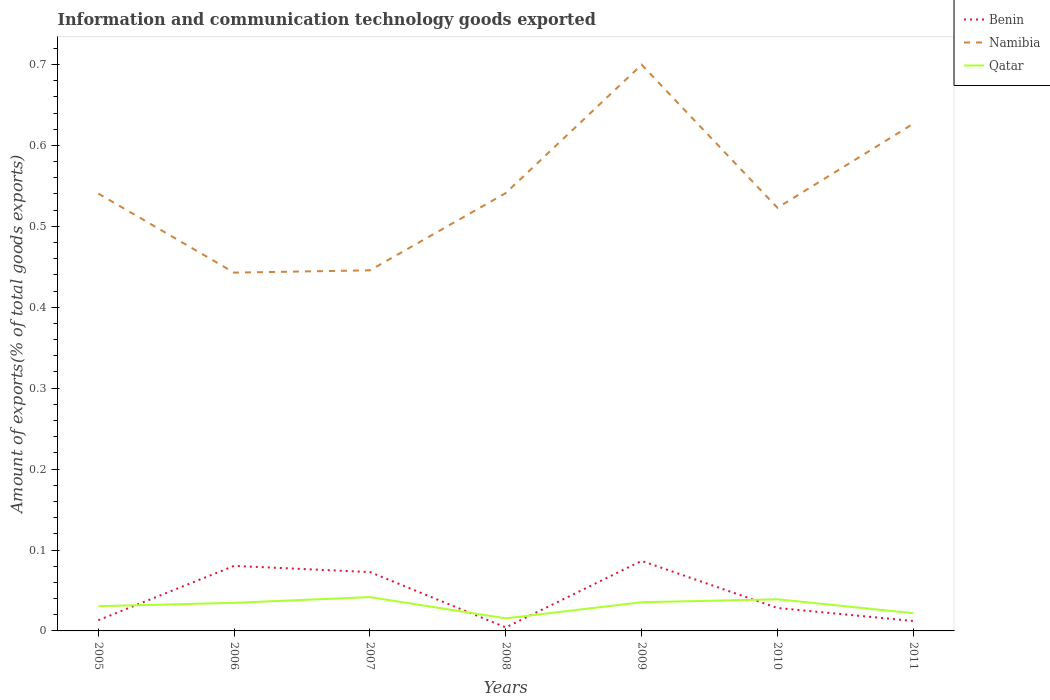How many different coloured lines are there?
Keep it short and to the point. 3. Does the line corresponding to Namibia intersect with the line corresponding to Qatar?
Your answer should be compact. No. Is the number of lines equal to the number of legend labels?
Your answer should be compact. Yes. Across all years, what is the maximum amount of goods exported in Benin?
Your response must be concise. 0. What is the total amount of goods exported in Qatar in the graph?
Offer a terse response. -0. What is the difference between the highest and the second highest amount of goods exported in Namibia?
Keep it short and to the point. 0.26. What is the difference between the highest and the lowest amount of goods exported in Benin?
Provide a succinct answer. 3. Are the values on the major ticks of Y-axis written in scientific E-notation?
Your answer should be very brief. No. Does the graph contain any zero values?
Your response must be concise. No. How many legend labels are there?
Provide a succinct answer. 3. What is the title of the graph?
Provide a short and direct response. Information and communication technology goods exported. What is the label or title of the Y-axis?
Give a very brief answer. Amount of exports(% of total goods exports). What is the Amount of exports(% of total goods exports) of Benin in 2005?
Provide a short and direct response. 0.01. What is the Amount of exports(% of total goods exports) of Namibia in 2005?
Offer a very short reply. 0.54. What is the Amount of exports(% of total goods exports) in Qatar in 2005?
Offer a very short reply. 0.03. What is the Amount of exports(% of total goods exports) of Benin in 2006?
Make the answer very short. 0.08. What is the Amount of exports(% of total goods exports) in Namibia in 2006?
Provide a succinct answer. 0.44. What is the Amount of exports(% of total goods exports) in Qatar in 2006?
Your response must be concise. 0.03. What is the Amount of exports(% of total goods exports) of Benin in 2007?
Give a very brief answer. 0.07. What is the Amount of exports(% of total goods exports) in Namibia in 2007?
Your answer should be compact. 0.45. What is the Amount of exports(% of total goods exports) of Qatar in 2007?
Provide a short and direct response. 0.04. What is the Amount of exports(% of total goods exports) in Benin in 2008?
Offer a very short reply. 0. What is the Amount of exports(% of total goods exports) in Namibia in 2008?
Ensure brevity in your answer.  0.54. What is the Amount of exports(% of total goods exports) in Qatar in 2008?
Ensure brevity in your answer.  0.02. What is the Amount of exports(% of total goods exports) in Benin in 2009?
Provide a short and direct response. 0.09. What is the Amount of exports(% of total goods exports) of Namibia in 2009?
Make the answer very short. 0.7. What is the Amount of exports(% of total goods exports) of Qatar in 2009?
Provide a short and direct response. 0.04. What is the Amount of exports(% of total goods exports) in Benin in 2010?
Ensure brevity in your answer.  0.03. What is the Amount of exports(% of total goods exports) of Namibia in 2010?
Provide a succinct answer. 0.52. What is the Amount of exports(% of total goods exports) of Qatar in 2010?
Provide a succinct answer. 0.04. What is the Amount of exports(% of total goods exports) in Benin in 2011?
Make the answer very short. 0.01. What is the Amount of exports(% of total goods exports) of Namibia in 2011?
Ensure brevity in your answer.  0.63. What is the Amount of exports(% of total goods exports) of Qatar in 2011?
Offer a terse response. 0.02. Across all years, what is the maximum Amount of exports(% of total goods exports) of Benin?
Your response must be concise. 0.09. Across all years, what is the maximum Amount of exports(% of total goods exports) of Namibia?
Your answer should be compact. 0.7. Across all years, what is the maximum Amount of exports(% of total goods exports) in Qatar?
Give a very brief answer. 0.04. Across all years, what is the minimum Amount of exports(% of total goods exports) of Benin?
Your answer should be compact. 0. Across all years, what is the minimum Amount of exports(% of total goods exports) in Namibia?
Your answer should be very brief. 0.44. Across all years, what is the minimum Amount of exports(% of total goods exports) in Qatar?
Your answer should be compact. 0.02. What is the total Amount of exports(% of total goods exports) of Benin in the graph?
Keep it short and to the point. 0.3. What is the total Amount of exports(% of total goods exports) in Namibia in the graph?
Make the answer very short. 3.82. What is the total Amount of exports(% of total goods exports) in Qatar in the graph?
Keep it short and to the point. 0.22. What is the difference between the Amount of exports(% of total goods exports) in Benin in 2005 and that in 2006?
Offer a terse response. -0.07. What is the difference between the Amount of exports(% of total goods exports) of Namibia in 2005 and that in 2006?
Your response must be concise. 0.1. What is the difference between the Amount of exports(% of total goods exports) in Qatar in 2005 and that in 2006?
Offer a terse response. -0. What is the difference between the Amount of exports(% of total goods exports) of Benin in 2005 and that in 2007?
Provide a succinct answer. -0.06. What is the difference between the Amount of exports(% of total goods exports) of Namibia in 2005 and that in 2007?
Offer a terse response. 0.09. What is the difference between the Amount of exports(% of total goods exports) of Qatar in 2005 and that in 2007?
Your answer should be very brief. -0.01. What is the difference between the Amount of exports(% of total goods exports) in Benin in 2005 and that in 2008?
Provide a short and direct response. 0.01. What is the difference between the Amount of exports(% of total goods exports) of Namibia in 2005 and that in 2008?
Your answer should be very brief. -0. What is the difference between the Amount of exports(% of total goods exports) in Qatar in 2005 and that in 2008?
Ensure brevity in your answer.  0.01. What is the difference between the Amount of exports(% of total goods exports) in Benin in 2005 and that in 2009?
Your response must be concise. -0.07. What is the difference between the Amount of exports(% of total goods exports) in Namibia in 2005 and that in 2009?
Ensure brevity in your answer.  -0.16. What is the difference between the Amount of exports(% of total goods exports) of Qatar in 2005 and that in 2009?
Offer a terse response. -0. What is the difference between the Amount of exports(% of total goods exports) of Benin in 2005 and that in 2010?
Your answer should be very brief. -0.02. What is the difference between the Amount of exports(% of total goods exports) in Namibia in 2005 and that in 2010?
Ensure brevity in your answer.  0.02. What is the difference between the Amount of exports(% of total goods exports) in Qatar in 2005 and that in 2010?
Offer a terse response. -0.01. What is the difference between the Amount of exports(% of total goods exports) of Namibia in 2005 and that in 2011?
Provide a short and direct response. -0.09. What is the difference between the Amount of exports(% of total goods exports) of Qatar in 2005 and that in 2011?
Keep it short and to the point. 0.01. What is the difference between the Amount of exports(% of total goods exports) in Benin in 2006 and that in 2007?
Make the answer very short. 0.01. What is the difference between the Amount of exports(% of total goods exports) of Namibia in 2006 and that in 2007?
Ensure brevity in your answer.  -0. What is the difference between the Amount of exports(% of total goods exports) in Qatar in 2006 and that in 2007?
Give a very brief answer. -0.01. What is the difference between the Amount of exports(% of total goods exports) of Benin in 2006 and that in 2008?
Make the answer very short. 0.08. What is the difference between the Amount of exports(% of total goods exports) in Namibia in 2006 and that in 2008?
Ensure brevity in your answer.  -0.1. What is the difference between the Amount of exports(% of total goods exports) in Qatar in 2006 and that in 2008?
Provide a succinct answer. 0.02. What is the difference between the Amount of exports(% of total goods exports) of Benin in 2006 and that in 2009?
Make the answer very short. -0.01. What is the difference between the Amount of exports(% of total goods exports) in Namibia in 2006 and that in 2009?
Ensure brevity in your answer.  -0.26. What is the difference between the Amount of exports(% of total goods exports) of Qatar in 2006 and that in 2009?
Ensure brevity in your answer.  -0. What is the difference between the Amount of exports(% of total goods exports) of Benin in 2006 and that in 2010?
Make the answer very short. 0.05. What is the difference between the Amount of exports(% of total goods exports) of Namibia in 2006 and that in 2010?
Your response must be concise. -0.08. What is the difference between the Amount of exports(% of total goods exports) in Qatar in 2006 and that in 2010?
Ensure brevity in your answer.  -0. What is the difference between the Amount of exports(% of total goods exports) in Benin in 2006 and that in 2011?
Keep it short and to the point. 0.07. What is the difference between the Amount of exports(% of total goods exports) of Namibia in 2006 and that in 2011?
Your answer should be very brief. -0.18. What is the difference between the Amount of exports(% of total goods exports) in Qatar in 2006 and that in 2011?
Ensure brevity in your answer.  0.01. What is the difference between the Amount of exports(% of total goods exports) of Benin in 2007 and that in 2008?
Offer a very short reply. 0.07. What is the difference between the Amount of exports(% of total goods exports) in Namibia in 2007 and that in 2008?
Your answer should be very brief. -0.1. What is the difference between the Amount of exports(% of total goods exports) of Qatar in 2007 and that in 2008?
Offer a terse response. 0.03. What is the difference between the Amount of exports(% of total goods exports) in Benin in 2007 and that in 2009?
Your answer should be very brief. -0.01. What is the difference between the Amount of exports(% of total goods exports) of Namibia in 2007 and that in 2009?
Your answer should be compact. -0.25. What is the difference between the Amount of exports(% of total goods exports) of Qatar in 2007 and that in 2009?
Ensure brevity in your answer.  0.01. What is the difference between the Amount of exports(% of total goods exports) of Benin in 2007 and that in 2010?
Your response must be concise. 0.04. What is the difference between the Amount of exports(% of total goods exports) of Namibia in 2007 and that in 2010?
Give a very brief answer. -0.08. What is the difference between the Amount of exports(% of total goods exports) of Qatar in 2007 and that in 2010?
Make the answer very short. 0. What is the difference between the Amount of exports(% of total goods exports) in Benin in 2007 and that in 2011?
Offer a very short reply. 0.06. What is the difference between the Amount of exports(% of total goods exports) of Namibia in 2007 and that in 2011?
Provide a succinct answer. -0.18. What is the difference between the Amount of exports(% of total goods exports) of Qatar in 2007 and that in 2011?
Provide a succinct answer. 0.02. What is the difference between the Amount of exports(% of total goods exports) in Benin in 2008 and that in 2009?
Your answer should be very brief. -0.08. What is the difference between the Amount of exports(% of total goods exports) in Namibia in 2008 and that in 2009?
Provide a short and direct response. -0.16. What is the difference between the Amount of exports(% of total goods exports) in Qatar in 2008 and that in 2009?
Give a very brief answer. -0.02. What is the difference between the Amount of exports(% of total goods exports) of Benin in 2008 and that in 2010?
Your response must be concise. -0.02. What is the difference between the Amount of exports(% of total goods exports) in Namibia in 2008 and that in 2010?
Offer a very short reply. 0.02. What is the difference between the Amount of exports(% of total goods exports) of Qatar in 2008 and that in 2010?
Offer a terse response. -0.02. What is the difference between the Amount of exports(% of total goods exports) of Benin in 2008 and that in 2011?
Offer a terse response. -0.01. What is the difference between the Amount of exports(% of total goods exports) in Namibia in 2008 and that in 2011?
Offer a terse response. -0.09. What is the difference between the Amount of exports(% of total goods exports) of Qatar in 2008 and that in 2011?
Give a very brief answer. -0.01. What is the difference between the Amount of exports(% of total goods exports) in Benin in 2009 and that in 2010?
Ensure brevity in your answer.  0.06. What is the difference between the Amount of exports(% of total goods exports) in Namibia in 2009 and that in 2010?
Offer a very short reply. 0.18. What is the difference between the Amount of exports(% of total goods exports) in Qatar in 2009 and that in 2010?
Ensure brevity in your answer.  -0. What is the difference between the Amount of exports(% of total goods exports) in Benin in 2009 and that in 2011?
Provide a short and direct response. 0.07. What is the difference between the Amount of exports(% of total goods exports) in Namibia in 2009 and that in 2011?
Offer a terse response. 0.07. What is the difference between the Amount of exports(% of total goods exports) in Qatar in 2009 and that in 2011?
Give a very brief answer. 0.01. What is the difference between the Amount of exports(% of total goods exports) in Benin in 2010 and that in 2011?
Provide a succinct answer. 0.02. What is the difference between the Amount of exports(% of total goods exports) of Namibia in 2010 and that in 2011?
Offer a very short reply. -0.1. What is the difference between the Amount of exports(% of total goods exports) of Qatar in 2010 and that in 2011?
Offer a terse response. 0.02. What is the difference between the Amount of exports(% of total goods exports) in Benin in 2005 and the Amount of exports(% of total goods exports) in Namibia in 2006?
Provide a short and direct response. -0.43. What is the difference between the Amount of exports(% of total goods exports) in Benin in 2005 and the Amount of exports(% of total goods exports) in Qatar in 2006?
Provide a succinct answer. -0.02. What is the difference between the Amount of exports(% of total goods exports) of Namibia in 2005 and the Amount of exports(% of total goods exports) of Qatar in 2006?
Keep it short and to the point. 0.51. What is the difference between the Amount of exports(% of total goods exports) in Benin in 2005 and the Amount of exports(% of total goods exports) in Namibia in 2007?
Offer a terse response. -0.43. What is the difference between the Amount of exports(% of total goods exports) in Benin in 2005 and the Amount of exports(% of total goods exports) in Qatar in 2007?
Provide a short and direct response. -0.03. What is the difference between the Amount of exports(% of total goods exports) of Namibia in 2005 and the Amount of exports(% of total goods exports) of Qatar in 2007?
Ensure brevity in your answer.  0.5. What is the difference between the Amount of exports(% of total goods exports) in Benin in 2005 and the Amount of exports(% of total goods exports) in Namibia in 2008?
Keep it short and to the point. -0.53. What is the difference between the Amount of exports(% of total goods exports) of Benin in 2005 and the Amount of exports(% of total goods exports) of Qatar in 2008?
Make the answer very short. -0. What is the difference between the Amount of exports(% of total goods exports) of Namibia in 2005 and the Amount of exports(% of total goods exports) of Qatar in 2008?
Give a very brief answer. 0.53. What is the difference between the Amount of exports(% of total goods exports) of Benin in 2005 and the Amount of exports(% of total goods exports) of Namibia in 2009?
Offer a very short reply. -0.69. What is the difference between the Amount of exports(% of total goods exports) in Benin in 2005 and the Amount of exports(% of total goods exports) in Qatar in 2009?
Make the answer very short. -0.02. What is the difference between the Amount of exports(% of total goods exports) of Namibia in 2005 and the Amount of exports(% of total goods exports) of Qatar in 2009?
Ensure brevity in your answer.  0.51. What is the difference between the Amount of exports(% of total goods exports) of Benin in 2005 and the Amount of exports(% of total goods exports) of Namibia in 2010?
Your answer should be very brief. -0.51. What is the difference between the Amount of exports(% of total goods exports) in Benin in 2005 and the Amount of exports(% of total goods exports) in Qatar in 2010?
Provide a short and direct response. -0.03. What is the difference between the Amount of exports(% of total goods exports) in Namibia in 2005 and the Amount of exports(% of total goods exports) in Qatar in 2010?
Provide a short and direct response. 0.5. What is the difference between the Amount of exports(% of total goods exports) of Benin in 2005 and the Amount of exports(% of total goods exports) of Namibia in 2011?
Provide a succinct answer. -0.61. What is the difference between the Amount of exports(% of total goods exports) in Benin in 2005 and the Amount of exports(% of total goods exports) in Qatar in 2011?
Offer a very short reply. -0.01. What is the difference between the Amount of exports(% of total goods exports) of Namibia in 2005 and the Amount of exports(% of total goods exports) of Qatar in 2011?
Keep it short and to the point. 0.52. What is the difference between the Amount of exports(% of total goods exports) of Benin in 2006 and the Amount of exports(% of total goods exports) of Namibia in 2007?
Keep it short and to the point. -0.37. What is the difference between the Amount of exports(% of total goods exports) of Benin in 2006 and the Amount of exports(% of total goods exports) of Qatar in 2007?
Give a very brief answer. 0.04. What is the difference between the Amount of exports(% of total goods exports) in Namibia in 2006 and the Amount of exports(% of total goods exports) in Qatar in 2007?
Your answer should be very brief. 0.4. What is the difference between the Amount of exports(% of total goods exports) of Benin in 2006 and the Amount of exports(% of total goods exports) of Namibia in 2008?
Give a very brief answer. -0.46. What is the difference between the Amount of exports(% of total goods exports) of Benin in 2006 and the Amount of exports(% of total goods exports) of Qatar in 2008?
Your answer should be very brief. 0.06. What is the difference between the Amount of exports(% of total goods exports) in Namibia in 2006 and the Amount of exports(% of total goods exports) in Qatar in 2008?
Provide a succinct answer. 0.43. What is the difference between the Amount of exports(% of total goods exports) of Benin in 2006 and the Amount of exports(% of total goods exports) of Namibia in 2009?
Provide a short and direct response. -0.62. What is the difference between the Amount of exports(% of total goods exports) in Benin in 2006 and the Amount of exports(% of total goods exports) in Qatar in 2009?
Give a very brief answer. 0.04. What is the difference between the Amount of exports(% of total goods exports) of Namibia in 2006 and the Amount of exports(% of total goods exports) of Qatar in 2009?
Give a very brief answer. 0.41. What is the difference between the Amount of exports(% of total goods exports) of Benin in 2006 and the Amount of exports(% of total goods exports) of Namibia in 2010?
Give a very brief answer. -0.44. What is the difference between the Amount of exports(% of total goods exports) of Benin in 2006 and the Amount of exports(% of total goods exports) of Qatar in 2010?
Offer a very short reply. 0.04. What is the difference between the Amount of exports(% of total goods exports) of Namibia in 2006 and the Amount of exports(% of total goods exports) of Qatar in 2010?
Your answer should be compact. 0.4. What is the difference between the Amount of exports(% of total goods exports) in Benin in 2006 and the Amount of exports(% of total goods exports) in Namibia in 2011?
Offer a terse response. -0.55. What is the difference between the Amount of exports(% of total goods exports) in Benin in 2006 and the Amount of exports(% of total goods exports) in Qatar in 2011?
Your answer should be compact. 0.06. What is the difference between the Amount of exports(% of total goods exports) in Namibia in 2006 and the Amount of exports(% of total goods exports) in Qatar in 2011?
Give a very brief answer. 0.42. What is the difference between the Amount of exports(% of total goods exports) of Benin in 2007 and the Amount of exports(% of total goods exports) of Namibia in 2008?
Give a very brief answer. -0.47. What is the difference between the Amount of exports(% of total goods exports) of Benin in 2007 and the Amount of exports(% of total goods exports) of Qatar in 2008?
Provide a short and direct response. 0.06. What is the difference between the Amount of exports(% of total goods exports) in Namibia in 2007 and the Amount of exports(% of total goods exports) in Qatar in 2008?
Offer a terse response. 0.43. What is the difference between the Amount of exports(% of total goods exports) in Benin in 2007 and the Amount of exports(% of total goods exports) in Namibia in 2009?
Give a very brief answer. -0.63. What is the difference between the Amount of exports(% of total goods exports) in Benin in 2007 and the Amount of exports(% of total goods exports) in Qatar in 2009?
Give a very brief answer. 0.04. What is the difference between the Amount of exports(% of total goods exports) in Namibia in 2007 and the Amount of exports(% of total goods exports) in Qatar in 2009?
Your response must be concise. 0.41. What is the difference between the Amount of exports(% of total goods exports) in Benin in 2007 and the Amount of exports(% of total goods exports) in Namibia in 2010?
Offer a terse response. -0.45. What is the difference between the Amount of exports(% of total goods exports) of Benin in 2007 and the Amount of exports(% of total goods exports) of Qatar in 2010?
Give a very brief answer. 0.03. What is the difference between the Amount of exports(% of total goods exports) in Namibia in 2007 and the Amount of exports(% of total goods exports) in Qatar in 2010?
Keep it short and to the point. 0.41. What is the difference between the Amount of exports(% of total goods exports) in Benin in 2007 and the Amount of exports(% of total goods exports) in Namibia in 2011?
Offer a terse response. -0.55. What is the difference between the Amount of exports(% of total goods exports) in Benin in 2007 and the Amount of exports(% of total goods exports) in Qatar in 2011?
Provide a short and direct response. 0.05. What is the difference between the Amount of exports(% of total goods exports) of Namibia in 2007 and the Amount of exports(% of total goods exports) of Qatar in 2011?
Offer a very short reply. 0.42. What is the difference between the Amount of exports(% of total goods exports) of Benin in 2008 and the Amount of exports(% of total goods exports) of Namibia in 2009?
Ensure brevity in your answer.  -0.7. What is the difference between the Amount of exports(% of total goods exports) in Benin in 2008 and the Amount of exports(% of total goods exports) in Qatar in 2009?
Your answer should be compact. -0.03. What is the difference between the Amount of exports(% of total goods exports) in Namibia in 2008 and the Amount of exports(% of total goods exports) in Qatar in 2009?
Provide a short and direct response. 0.51. What is the difference between the Amount of exports(% of total goods exports) of Benin in 2008 and the Amount of exports(% of total goods exports) of Namibia in 2010?
Ensure brevity in your answer.  -0.52. What is the difference between the Amount of exports(% of total goods exports) of Benin in 2008 and the Amount of exports(% of total goods exports) of Qatar in 2010?
Make the answer very short. -0.03. What is the difference between the Amount of exports(% of total goods exports) of Namibia in 2008 and the Amount of exports(% of total goods exports) of Qatar in 2010?
Offer a very short reply. 0.5. What is the difference between the Amount of exports(% of total goods exports) of Benin in 2008 and the Amount of exports(% of total goods exports) of Namibia in 2011?
Give a very brief answer. -0.62. What is the difference between the Amount of exports(% of total goods exports) in Benin in 2008 and the Amount of exports(% of total goods exports) in Qatar in 2011?
Give a very brief answer. -0.02. What is the difference between the Amount of exports(% of total goods exports) of Namibia in 2008 and the Amount of exports(% of total goods exports) of Qatar in 2011?
Your response must be concise. 0.52. What is the difference between the Amount of exports(% of total goods exports) of Benin in 2009 and the Amount of exports(% of total goods exports) of Namibia in 2010?
Keep it short and to the point. -0.44. What is the difference between the Amount of exports(% of total goods exports) in Benin in 2009 and the Amount of exports(% of total goods exports) in Qatar in 2010?
Your answer should be compact. 0.05. What is the difference between the Amount of exports(% of total goods exports) of Namibia in 2009 and the Amount of exports(% of total goods exports) of Qatar in 2010?
Offer a terse response. 0.66. What is the difference between the Amount of exports(% of total goods exports) of Benin in 2009 and the Amount of exports(% of total goods exports) of Namibia in 2011?
Your answer should be very brief. -0.54. What is the difference between the Amount of exports(% of total goods exports) in Benin in 2009 and the Amount of exports(% of total goods exports) in Qatar in 2011?
Provide a short and direct response. 0.06. What is the difference between the Amount of exports(% of total goods exports) of Namibia in 2009 and the Amount of exports(% of total goods exports) of Qatar in 2011?
Provide a succinct answer. 0.68. What is the difference between the Amount of exports(% of total goods exports) of Benin in 2010 and the Amount of exports(% of total goods exports) of Namibia in 2011?
Ensure brevity in your answer.  -0.6. What is the difference between the Amount of exports(% of total goods exports) in Benin in 2010 and the Amount of exports(% of total goods exports) in Qatar in 2011?
Ensure brevity in your answer.  0.01. What is the difference between the Amount of exports(% of total goods exports) in Namibia in 2010 and the Amount of exports(% of total goods exports) in Qatar in 2011?
Provide a short and direct response. 0.5. What is the average Amount of exports(% of total goods exports) of Benin per year?
Make the answer very short. 0.04. What is the average Amount of exports(% of total goods exports) in Namibia per year?
Your response must be concise. 0.55. What is the average Amount of exports(% of total goods exports) in Qatar per year?
Your response must be concise. 0.03. In the year 2005, what is the difference between the Amount of exports(% of total goods exports) of Benin and Amount of exports(% of total goods exports) of Namibia?
Your answer should be very brief. -0.53. In the year 2005, what is the difference between the Amount of exports(% of total goods exports) in Benin and Amount of exports(% of total goods exports) in Qatar?
Provide a short and direct response. -0.02. In the year 2005, what is the difference between the Amount of exports(% of total goods exports) of Namibia and Amount of exports(% of total goods exports) of Qatar?
Make the answer very short. 0.51. In the year 2006, what is the difference between the Amount of exports(% of total goods exports) in Benin and Amount of exports(% of total goods exports) in Namibia?
Provide a short and direct response. -0.36. In the year 2006, what is the difference between the Amount of exports(% of total goods exports) of Benin and Amount of exports(% of total goods exports) of Qatar?
Make the answer very short. 0.05. In the year 2006, what is the difference between the Amount of exports(% of total goods exports) of Namibia and Amount of exports(% of total goods exports) of Qatar?
Ensure brevity in your answer.  0.41. In the year 2007, what is the difference between the Amount of exports(% of total goods exports) in Benin and Amount of exports(% of total goods exports) in Namibia?
Your answer should be very brief. -0.37. In the year 2007, what is the difference between the Amount of exports(% of total goods exports) in Benin and Amount of exports(% of total goods exports) in Qatar?
Your answer should be compact. 0.03. In the year 2007, what is the difference between the Amount of exports(% of total goods exports) in Namibia and Amount of exports(% of total goods exports) in Qatar?
Your response must be concise. 0.4. In the year 2008, what is the difference between the Amount of exports(% of total goods exports) of Benin and Amount of exports(% of total goods exports) of Namibia?
Give a very brief answer. -0.54. In the year 2008, what is the difference between the Amount of exports(% of total goods exports) of Benin and Amount of exports(% of total goods exports) of Qatar?
Your response must be concise. -0.01. In the year 2008, what is the difference between the Amount of exports(% of total goods exports) in Namibia and Amount of exports(% of total goods exports) in Qatar?
Offer a very short reply. 0.53. In the year 2009, what is the difference between the Amount of exports(% of total goods exports) in Benin and Amount of exports(% of total goods exports) in Namibia?
Keep it short and to the point. -0.61. In the year 2009, what is the difference between the Amount of exports(% of total goods exports) in Benin and Amount of exports(% of total goods exports) in Qatar?
Ensure brevity in your answer.  0.05. In the year 2009, what is the difference between the Amount of exports(% of total goods exports) of Namibia and Amount of exports(% of total goods exports) of Qatar?
Make the answer very short. 0.66. In the year 2010, what is the difference between the Amount of exports(% of total goods exports) in Benin and Amount of exports(% of total goods exports) in Namibia?
Offer a terse response. -0.49. In the year 2010, what is the difference between the Amount of exports(% of total goods exports) of Benin and Amount of exports(% of total goods exports) of Qatar?
Offer a terse response. -0.01. In the year 2010, what is the difference between the Amount of exports(% of total goods exports) of Namibia and Amount of exports(% of total goods exports) of Qatar?
Keep it short and to the point. 0.48. In the year 2011, what is the difference between the Amount of exports(% of total goods exports) of Benin and Amount of exports(% of total goods exports) of Namibia?
Your response must be concise. -0.61. In the year 2011, what is the difference between the Amount of exports(% of total goods exports) of Benin and Amount of exports(% of total goods exports) of Qatar?
Your answer should be compact. -0.01. In the year 2011, what is the difference between the Amount of exports(% of total goods exports) of Namibia and Amount of exports(% of total goods exports) of Qatar?
Offer a terse response. 0.6. What is the ratio of the Amount of exports(% of total goods exports) of Benin in 2005 to that in 2006?
Provide a short and direct response. 0.17. What is the ratio of the Amount of exports(% of total goods exports) in Namibia in 2005 to that in 2006?
Offer a very short reply. 1.22. What is the ratio of the Amount of exports(% of total goods exports) in Qatar in 2005 to that in 2006?
Your answer should be compact. 0.88. What is the ratio of the Amount of exports(% of total goods exports) in Benin in 2005 to that in 2007?
Provide a succinct answer. 0.18. What is the ratio of the Amount of exports(% of total goods exports) of Namibia in 2005 to that in 2007?
Your answer should be compact. 1.21. What is the ratio of the Amount of exports(% of total goods exports) of Qatar in 2005 to that in 2007?
Give a very brief answer. 0.73. What is the ratio of the Amount of exports(% of total goods exports) in Benin in 2005 to that in 2008?
Your answer should be compact. 3.06. What is the ratio of the Amount of exports(% of total goods exports) of Qatar in 2005 to that in 2008?
Your response must be concise. 1.97. What is the ratio of the Amount of exports(% of total goods exports) in Benin in 2005 to that in 2009?
Keep it short and to the point. 0.15. What is the ratio of the Amount of exports(% of total goods exports) in Namibia in 2005 to that in 2009?
Ensure brevity in your answer.  0.77. What is the ratio of the Amount of exports(% of total goods exports) in Qatar in 2005 to that in 2009?
Offer a terse response. 0.86. What is the ratio of the Amount of exports(% of total goods exports) of Benin in 2005 to that in 2010?
Provide a short and direct response. 0.47. What is the ratio of the Amount of exports(% of total goods exports) in Namibia in 2005 to that in 2010?
Offer a terse response. 1.03. What is the ratio of the Amount of exports(% of total goods exports) in Qatar in 2005 to that in 2010?
Offer a very short reply. 0.78. What is the ratio of the Amount of exports(% of total goods exports) in Benin in 2005 to that in 2011?
Give a very brief answer. 1.08. What is the ratio of the Amount of exports(% of total goods exports) of Namibia in 2005 to that in 2011?
Make the answer very short. 0.86. What is the ratio of the Amount of exports(% of total goods exports) of Qatar in 2005 to that in 2011?
Your answer should be very brief. 1.4. What is the ratio of the Amount of exports(% of total goods exports) of Benin in 2006 to that in 2007?
Offer a very short reply. 1.11. What is the ratio of the Amount of exports(% of total goods exports) of Namibia in 2006 to that in 2007?
Your answer should be compact. 0.99. What is the ratio of the Amount of exports(% of total goods exports) of Qatar in 2006 to that in 2007?
Provide a succinct answer. 0.83. What is the ratio of the Amount of exports(% of total goods exports) in Benin in 2006 to that in 2008?
Provide a succinct answer. 18.57. What is the ratio of the Amount of exports(% of total goods exports) in Namibia in 2006 to that in 2008?
Give a very brief answer. 0.82. What is the ratio of the Amount of exports(% of total goods exports) in Qatar in 2006 to that in 2008?
Your answer should be very brief. 2.23. What is the ratio of the Amount of exports(% of total goods exports) of Benin in 2006 to that in 2009?
Give a very brief answer. 0.93. What is the ratio of the Amount of exports(% of total goods exports) in Namibia in 2006 to that in 2009?
Keep it short and to the point. 0.63. What is the ratio of the Amount of exports(% of total goods exports) of Qatar in 2006 to that in 2009?
Keep it short and to the point. 0.98. What is the ratio of the Amount of exports(% of total goods exports) of Benin in 2006 to that in 2010?
Offer a very short reply. 2.83. What is the ratio of the Amount of exports(% of total goods exports) in Namibia in 2006 to that in 2010?
Make the answer very short. 0.85. What is the ratio of the Amount of exports(% of total goods exports) in Qatar in 2006 to that in 2010?
Ensure brevity in your answer.  0.89. What is the ratio of the Amount of exports(% of total goods exports) of Benin in 2006 to that in 2011?
Offer a very short reply. 6.56. What is the ratio of the Amount of exports(% of total goods exports) in Namibia in 2006 to that in 2011?
Offer a terse response. 0.71. What is the ratio of the Amount of exports(% of total goods exports) in Qatar in 2006 to that in 2011?
Your answer should be compact. 1.59. What is the ratio of the Amount of exports(% of total goods exports) in Benin in 2007 to that in 2008?
Make the answer very short. 16.81. What is the ratio of the Amount of exports(% of total goods exports) in Namibia in 2007 to that in 2008?
Offer a very short reply. 0.82. What is the ratio of the Amount of exports(% of total goods exports) of Qatar in 2007 to that in 2008?
Give a very brief answer. 2.69. What is the ratio of the Amount of exports(% of total goods exports) in Benin in 2007 to that in 2009?
Ensure brevity in your answer.  0.84. What is the ratio of the Amount of exports(% of total goods exports) in Namibia in 2007 to that in 2009?
Your response must be concise. 0.64. What is the ratio of the Amount of exports(% of total goods exports) of Qatar in 2007 to that in 2009?
Your response must be concise. 1.18. What is the ratio of the Amount of exports(% of total goods exports) of Benin in 2007 to that in 2010?
Provide a succinct answer. 2.56. What is the ratio of the Amount of exports(% of total goods exports) in Namibia in 2007 to that in 2010?
Offer a terse response. 0.85. What is the ratio of the Amount of exports(% of total goods exports) of Qatar in 2007 to that in 2010?
Offer a very short reply. 1.07. What is the ratio of the Amount of exports(% of total goods exports) in Benin in 2007 to that in 2011?
Your answer should be compact. 5.93. What is the ratio of the Amount of exports(% of total goods exports) in Namibia in 2007 to that in 2011?
Offer a terse response. 0.71. What is the ratio of the Amount of exports(% of total goods exports) of Qatar in 2007 to that in 2011?
Your answer should be very brief. 1.91. What is the ratio of the Amount of exports(% of total goods exports) of Benin in 2008 to that in 2009?
Provide a short and direct response. 0.05. What is the ratio of the Amount of exports(% of total goods exports) in Namibia in 2008 to that in 2009?
Keep it short and to the point. 0.77. What is the ratio of the Amount of exports(% of total goods exports) of Qatar in 2008 to that in 2009?
Provide a short and direct response. 0.44. What is the ratio of the Amount of exports(% of total goods exports) of Benin in 2008 to that in 2010?
Your answer should be compact. 0.15. What is the ratio of the Amount of exports(% of total goods exports) in Namibia in 2008 to that in 2010?
Offer a terse response. 1.03. What is the ratio of the Amount of exports(% of total goods exports) of Qatar in 2008 to that in 2010?
Your answer should be very brief. 0.4. What is the ratio of the Amount of exports(% of total goods exports) in Benin in 2008 to that in 2011?
Offer a very short reply. 0.35. What is the ratio of the Amount of exports(% of total goods exports) of Namibia in 2008 to that in 2011?
Your answer should be compact. 0.86. What is the ratio of the Amount of exports(% of total goods exports) of Qatar in 2008 to that in 2011?
Make the answer very short. 0.71. What is the ratio of the Amount of exports(% of total goods exports) in Benin in 2009 to that in 2010?
Provide a succinct answer. 3.05. What is the ratio of the Amount of exports(% of total goods exports) in Namibia in 2009 to that in 2010?
Offer a terse response. 1.34. What is the ratio of the Amount of exports(% of total goods exports) of Qatar in 2009 to that in 2010?
Your response must be concise. 0.91. What is the ratio of the Amount of exports(% of total goods exports) in Benin in 2009 to that in 2011?
Your answer should be very brief. 7.06. What is the ratio of the Amount of exports(% of total goods exports) of Namibia in 2009 to that in 2011?
Your answer should be very brief. 1.12. What is the ratio of the Amount of exports(% of total goods exports) in Qatar in 2009 to that in 2011?
Make the answer very short. 1.62. What is the ratio of the Amount of exports(% of total goods exports) of Benin in 2010 to that in 2011?
Keep it short and to the point. 2.31. What is the ratio of the Amount of exports(% of total goods exports) in Namibia in 2010 to that in 2011?
Keep it short and to the point. 0.83. What is the ratio of the Amount of exports(% of total goods exports) in Qatar in 2010 to that in 2011?
Offer a very short reply. 1.79. What is the difference between the highest and the second highest Amount of exports(% of total goods exports) in Benin?
Provide a short and direct response. 0.01. What is the difference between the highest and the second highest Amount of exports(% of total goods exports) in Namibia?
Your answer should be compact. 0.07. What is the difference between the highest and the second highest Amount of exports(% of total goods exports) in Qatar?
Make the answer very short. 0. What is the difference between the highest and the lowest Amount of exports(% of total goods exports) in Benin?
Your answer should be very brief. 0.08. What is the difference between the highest and the lowest Amount of exports(% of total goods exports) of Namibia?
Provide a short and direct response. 0.26. What is the difference between the highest and the lowest Amount of exports(% of total goods exports) in Qatar?
Provide a succinct answer. 0.03. 